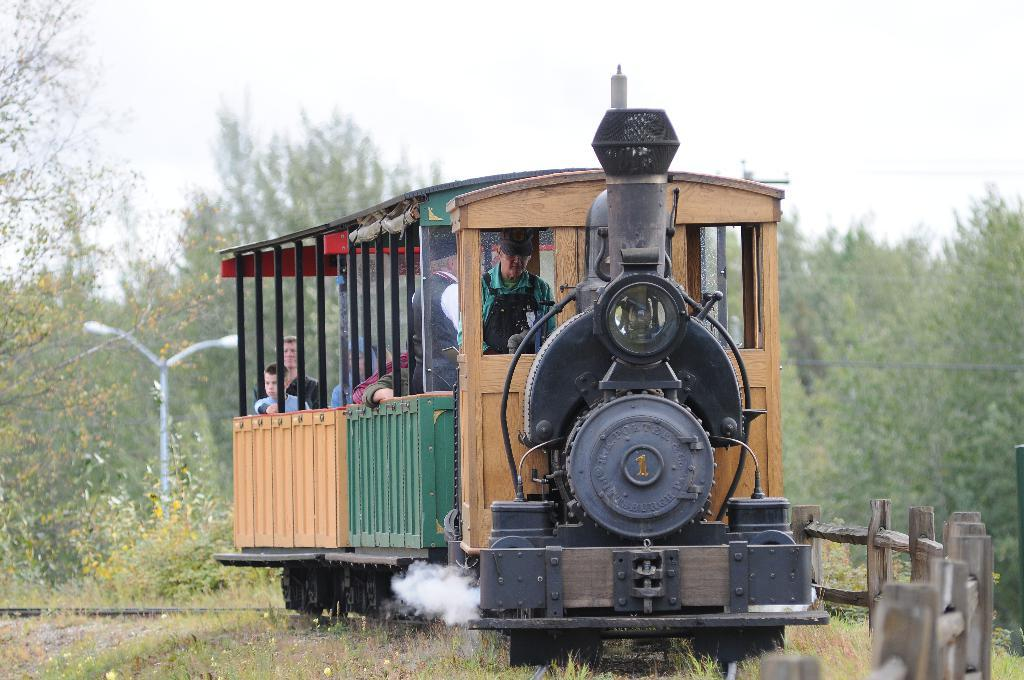What is the main subject of the image? The main subject of the image is a train on the track. What type of vegetation can be seen in the image? Grass is visible in the image. What is the barrier between the train and the grass? There is a fence in the image. What can be seen in the background of the image? Trees are present in the background of the image. What is visible at the top of the image? The sky is visible at the top of the image. When was the image taken? The image was taken during the day. What is the annual income of the car parked near the train in the image? There is no car present in the image, so it is not possible to determine its annual income. 